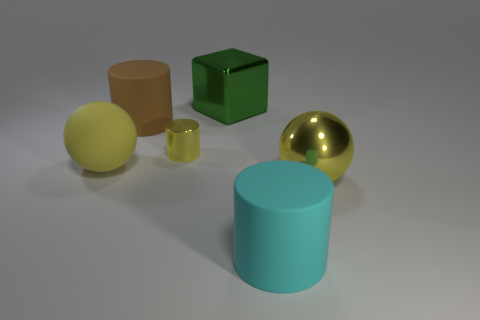There is a cylinder that is the same color as the matte sphere; what size is it?
Offer a very short reply. Small. Does the tiny metal thing have the same color as the big matte sphere?
Ensure brevity in your answer.  Yes. What color is the big thing that is on the right side of the tiny shiny cylinder and on the left side of the large cyan cylinder?
Provide a succinct answer. Green. What number of cubes are either large blue things or green metallic things?
Give a very brief answer. 1. What number of purple cubes have the same size as the cyan cylinder?
Provide a short and direct response. 0. There is a large sphere that is to the left of the block; how many brown things are on the left side of it?
Your answer should be compact. 0. There is a cylinder that is both to the left of the big green thing and in front of the large brown cylinder; how big is it?
Provide a short and direct response. Small. Is the number of big cyan objects greater than the number of small cyan things?
Make the answer very short. Yes. Are there any rubber cylinders of the same color as the tiny metallic thing?
Provide a short and direct response. No. There is a yellow thing that is to the right of the green metal object; does it have the same size as the tiny yellow shiny cylinder?
Make the answer very short. No. 